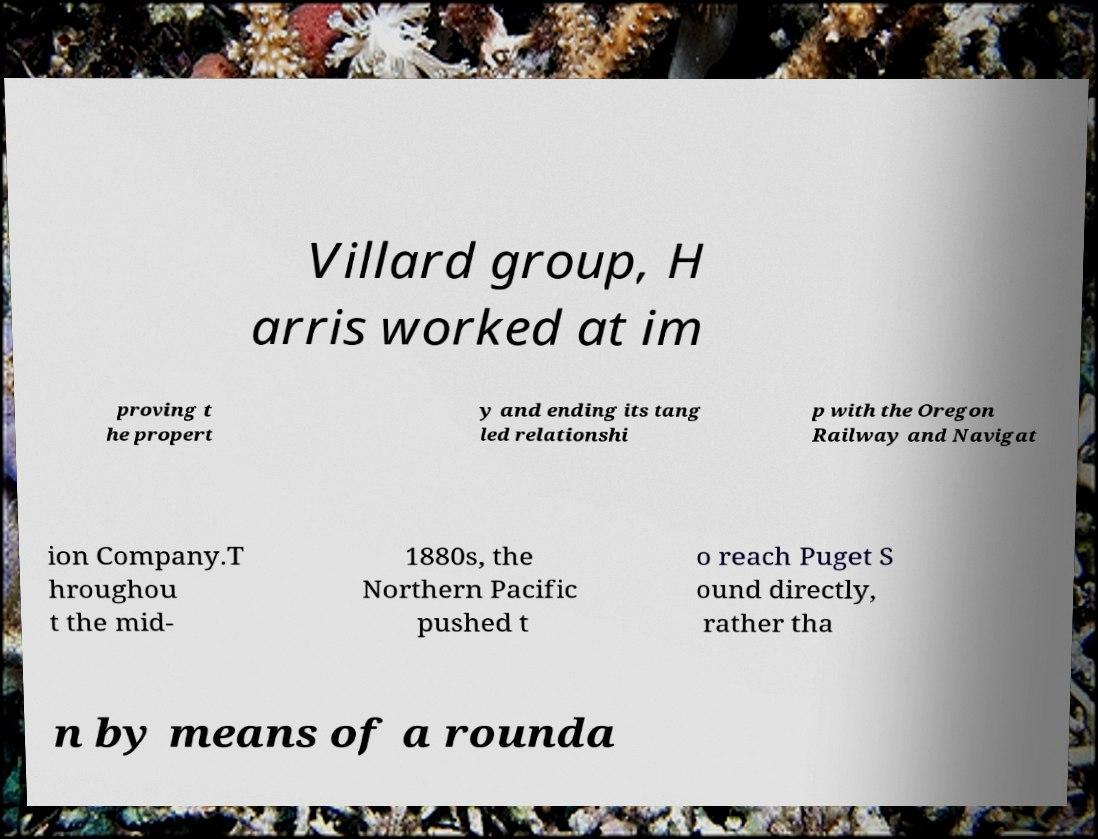I need the written content from this picture converted into text. Can you do that? Villard group, H arris worked at im proving t he propert y and ending its tang led relationshi p with the Oregon Railway and Navigat ion Company.T hroughou t the mid- 1880s, the Northern Pacific pushed t o reach Puget S ound directly, rather tha n by means of a rounda 